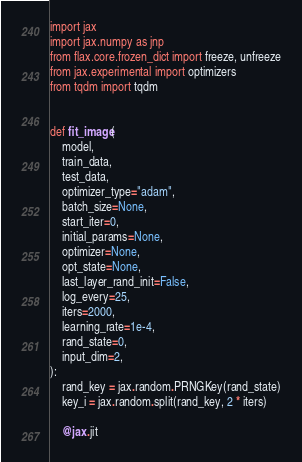<code> <loc_0><loc_0><loc_500><loc_500><_Python_>import jax
import jax.numpy as jnp
from flax.core.frozen_dict import freeze, unfreeze
from jax.experimental import optimizers
from tqdm import tqdm


def fit_image(
    model,
    train_data,
    test_data,
    optimizer_type="adam",
    batch_size=None,
    start_iter=0,
    initial_params=None,
    optimizer=None,
    opt_state=None,
    last_layer_rand_init=False,
    log_every=25,
    iters=2000,
    learning_rate=1e-4,
    rand_state=0,
    input_dim=2,
):
    rand_key = jax.random.PRNGKey(rand_state)
    key_i = jax.random.split(rand_key, 2 * iters)

    @jax.jit</code> 